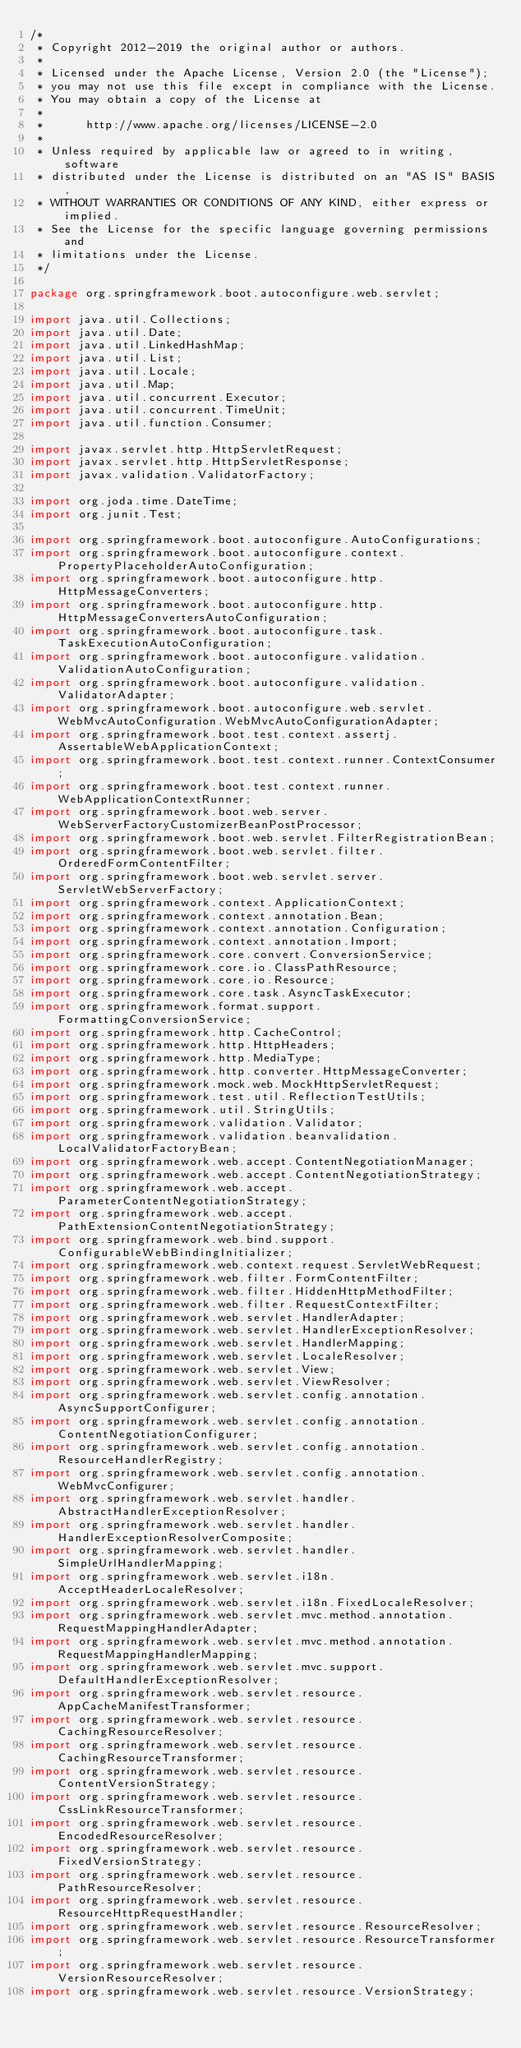<code> <loc_0><loc_0><loc_500><loc_500><_Java_>/*
 * Copyright 2012-2019 the original author or authors.
 *
 * Licensed under the Apache License, Version 2.0 (the "License");
 * you may not use this file except in compliance with the License.
 * You may obtain a copy of the License at
 *
 *      http://www.apache.org/licenses/LICENSE-2.0
 *
 * Unless required by applicable law or agreed to in writing, software
 * distributed under the License is distributed on an "AS IS" BASIS,
 * WITHOUT WARRANTIES OR CONDITIONS OF ANY KIND, either express or implied.
 * See the License for the specific language governing permissions and
 * limitations under the License.
 */

package org.springframework.boot.autoconfigure.web.servlet;

import java.util.Collections;
import java.util.Date;
import java.util.LinkedHashMap;
import java.util.List;
import java.util.Locale;
import java.util.Map;
import java.util.concurrent.Executor;
import java.util.concurrent.TimeUnit;
import java.util.function.Consumer;

import javax.servlet.http.HttpServletRequest;
import javax.servlet.http.HttpServletResponse;
import javax.validation.ValidatorFactory;

import org.joda.time.DateTime;
import org.junit.Test;

import org.springframework.boot.autoconfigure.AutoConfigurations;
import org.springframework.boot.autoconfigure.context.PropertyPlaceholderAutoConfiguration;
import org.springframework.boot.autoconfigure.http.HttpMessageConverters;
import org.springframework.boot.autoconfigure.http.HttpMessageConvertersAutoConfiguration;
import org.springframework.boot.autoconfigure.task.TaskExecutionAutoConfiguration;
import org.springframework.boot.autoconfigure.validation.ValidationAutoConfiguration;
import org.springframework.boot.autoconfigure.validation.ValidatorAdapter;
import org.springframework.boot.autoconfigure.web.servlet.WebMvcAutoConfiguration.WebMvcAutoConfigurationAdapter;
import org.springframework.boot.test.context.assertj.AssertableWebApplicationContext;
import org.springframework.boot.test.context.runner.ContextConsumer;
import org.springframework.boot.test.context.runner.WebApplicationContextRunner;
import org.springframework.boot.web.server.WebServerFactoryCustomizerBeanPostProcessor;
import org.springframework.boot.web.servlet.FilterRegistrationBean;
import org.springframework.boot.web.servlet.filter.OrderedFormContentFilter;
import org.springframework.boot.web.servlet.server.ServletWebServerFactory;
import org.springframework.context.ApplicationContext;
import org.springframework.context.annotation.Bean;
import org.springframework.context.annotation.Configuration;
import org.springframework.context.annotation.Import;
import org.springframework.core.convert.ConversionService;
import org.springframework.core.io.ClassPathResource;
import org.springframework.core.io.Resource;
import org.springframework.core.task.AsyncTaskExecutor;
import org.springframework.format.support.FormattingConversionService;
import org.springframework.http.CacheControl;
import org.springframework.http.HttpHeaders;
import org.springframework.http.MediaType;
import org.springframework.http.converter.HttpMessageConverter;
import org.springframework.mock.web.MockHttpServletRequest;
import org.springframework.test.util.ReflectionTestUtils;
import org.springframework.util.StringUtils;
import org.springframework.validation.Validator;
import org.springframework.validation.beanvalidation.LocalValidatorFactoryBean;
import org.springframework.web.accept.ContentNegotiationManager;
import org.springframework.web.accept.ContentNegotiationStrategy;
import org.springframework.web.accept.ParameterContentNegotiationStrategy;
import org.springframework.web.accept.PathExtensionContentNegotiationStrategy;
import org.springframework.web.bind.support.ConfigurableWebBindingInitializer;
import org.springframework.web.context.request.ServletWebRequest;
import org.springframework.web.filter.FormContentFilter;
import org.springframework.web.filter.HiddenHttpMethodFilter;
import org.springframework.web.filter.RequestContextFilter;
import org.springframework.web.servlet.HandlerAdapter;
import org.springframework.web.servlet.HandlerExceptionResolver;
import org.springframework.web.servlet.HandlerMapping;
import org.springframework.web.servlet.LocaleResolver;
import org.springframework.web.servlet.View;
import org.springframework.web.servlet.ViewResolver;
import org.springframework.web.servlet.config.annotation.AsyncSupportConfigurer;
import org.springframework.web.servlet.config.annotation.ContentNegotiationConfigurer;
import org.springframework.web.servlet.config.annotation.ResourceHandlerRegistry;
import org.springframework.web.servlet.config.annotation.WebMvcConfigurer;
import org.springframework.web.servlet.handler.AbstractHandlerExceptionResolver;
import org.springframework.web.servlet.handler.HandlerExceptionResolverComposite;
import org.springframework.web.servlet.handler.SimpleUrlHandlerMapping;
import org.springframework.web.servlet.i18n.AcceptHeaderLocaleResolver;
import org.springframework.web.servlet.i18n.FixedLocaleResolver;
import org.springframework.web.servlet.mvc.method.annotation.RequestMappingHandlerAdapter;
import org.springframework.web.servlet.mvc.method.annotation.RequestMappingHandlerMapping;
import org.springframework.web.servlet.mvc.support.DefaultHandlerExceptionResolver;
import org.springframework.web.servlet.resource.AppCacheManifestTransformer;
import org.springframework.web.servlet.resource.CachingResourceResolver;
import org.springframework.web.servlet.resource.CachingResourceTransformer;
import org.springframework.web.servlet.resource.ContentVersionStrategy;
import org.springframework.web.servlet.resource.CssLinkResourceTransformer;
import org.springframework.web.servlet.resource.EncodedResourceResolver;
import org.springframework.web.servlet.resource.FixedVersionStrategy;
import org.springframework.web.servlet.resource.PathResourceResolver;
import org.springframework.web.servlet.resource.ResourceHttpRequestHandler;
import org.springframework.web.servlet.resource.ResourceResolver;
import org.springframework.web.servlet.resource.ResourceTransformer;
import org.springframework.web.servlet.resource.VersionResourceResolver;
import org.springframework.web.servlet.resource.VersionStrategy;</code> 